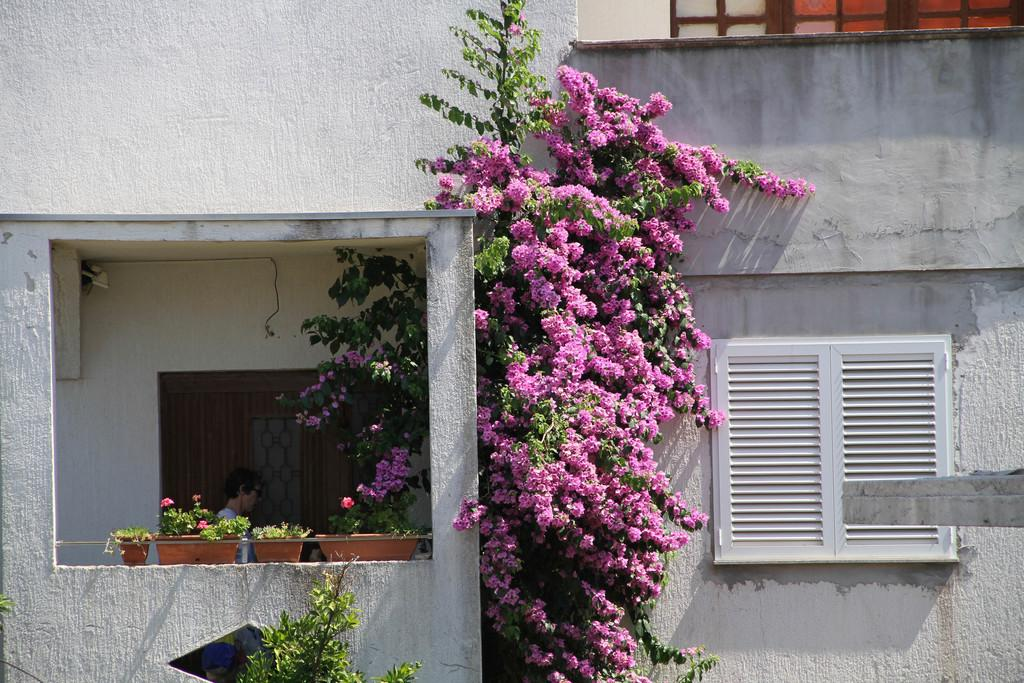What type of structure is present in the image? There is a building in the image. Can you describe the human figure in the image? A human is standing in the image. What kind of vegetation can be seen in the image? There are trees with flowers and plants in pots in the image. What architectural feature is visible in the image? There is a window in the image. What type of brake system is installed on the trees in the image? There is no brake system present in the image; it features trees with flowers and plants in pots. How does the human's stomach appear in the image? The image does not show the human's stomach; it only shows the standing figure. 